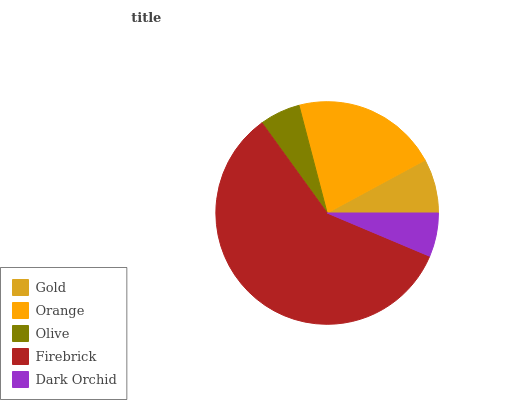Is Olive the minimum?
Answer yes or no. Yes. Is Firebrick the maximum?
Answer yes or no. Yes. Is Orange the minimum?
Answer yes or no. No. Is Orange the maximum?
Answer yes or no. No. Is Orange greater than Gold?
Answer yes or no. Yes. Is Gold less than Orange?
Answer yes or no. Yes. Is Gold greater than Orange?
Answer yes or no. No. Is Orange less than Gold?
Answer yes or no. No. Is Gold the high median?
Answer yes or no. Yes. Is Gold the low median?
Answer yes or no. Yes. Is Firebrick the high median?
Answer yes or no. No. Is Dark Orchid the low median?
Answer yes or no. No. 